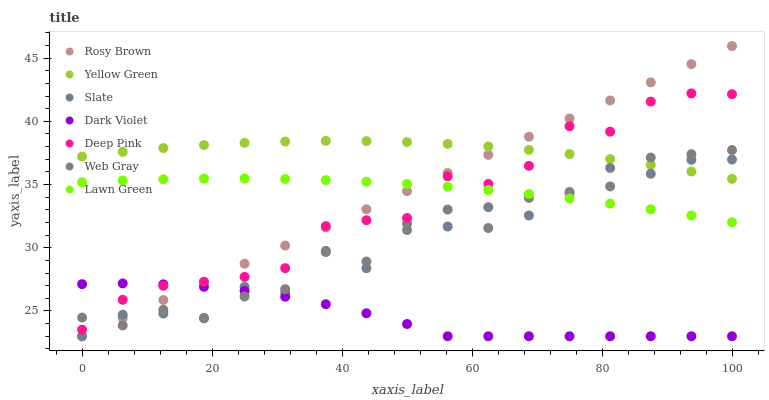Does Dark Violet have the minimum area under the curve?
Answer yes or no. Yes. Does Yellow Green have the maximum area under the curve?
Answer yes or no. Yes. Does Web Gray have the minimum area under the curve?
Answer yes or no. No. Does Web Gray have the maximum area under the curve?
Answer yes or no. No. Is Rosy Brown the smoothest?
Answer yes or no. Yes. Is Slate the roughest?
Answer yes or no. Yes. Is Web Gray the smoothest?
Answer yes or no. No. Is Web Gray the roughest?
Answer yes or no. No. Does Slate have the lowest value?
Answer yes or no. Yes. Does Web Gray have the lowest value?
Answer yes or no. No. Does Rosy Brown have the highest value?
Answer yes or no. Yes. Does Web Gray have the highest value?
Answer yes or no. No. Is Dark Violet less than Yellow Green?
Answer yes or no. Yes. Is Lawn Green greater than Dark Violet?
Answer yes or no. Yes. Does Web Gray intersect Yellow Green?
Answer yes or no. Yes. Is Web Gray less than Yellow Green?
Answer yes or no. No. Is Web Gray greater than Yellow Green?
Answer yes or no. No. Does Dark Violet intersect Yellow Green?
Answer yes or no. No. 